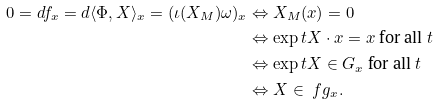Convert formula to latex. <formula><loc_0><loc_0><loc_500><loc_500>0 = d f _ { x } = d \langle \Phi , X \rangle _ { x } = ( \iota ( X _ { M } ) \omega ) _ { x } & \Leftrightarrow X _ { M } ( x ) = 0 \\ & \Leftrightarrow \exp t X \cdot x = x \text { for all } t \\ & \Leftrightarrow \exp t X \in G _ { x } \text { for all } t \\ & \Leftrightarrow X \in \ f g _ { x } . \\</formula> 